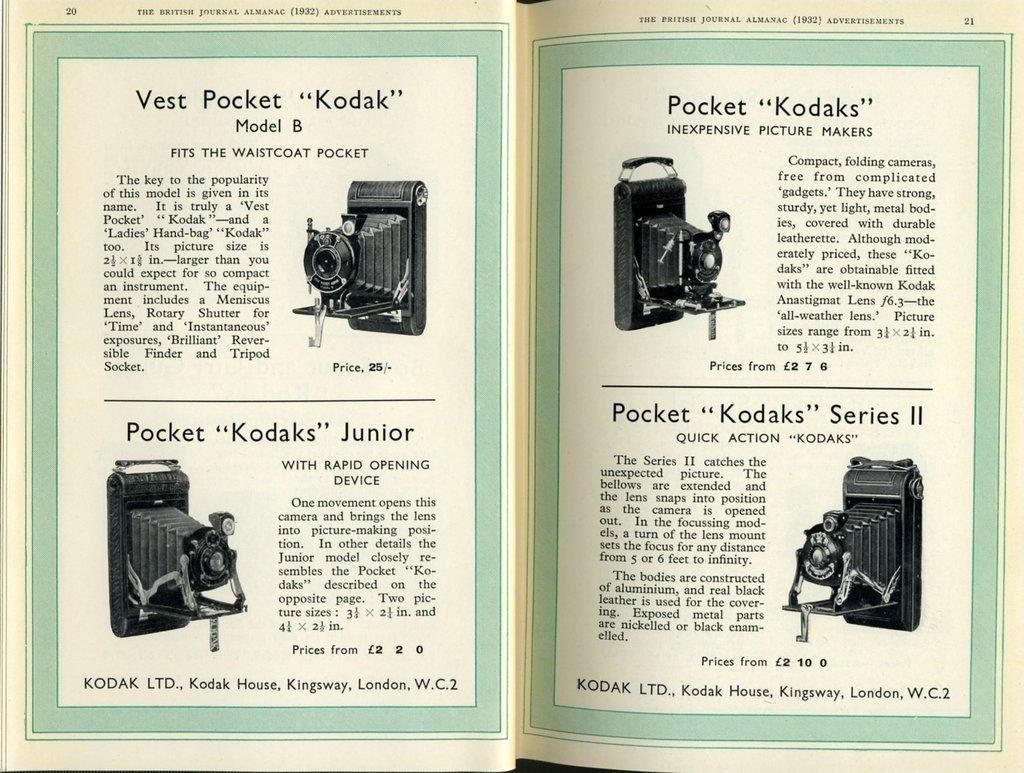Describe this image in one or two sentences. This is a book. In this picture we can see the cameras and text. 